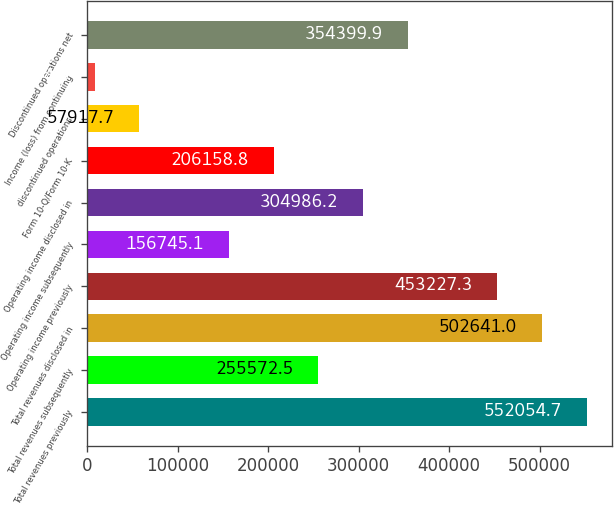<chart> <loc_0><loc_0><loc_500><loc_500><bar_chart><fcel>Total revenues previously<fcel>Total revenues subsequently<fcel>Total revenues disclosed in<fcel>Operating income previously<fcel>Operating income subsequently<fcel>Operating income disclosed in<fcel>Form 10-Q/Form 10-K<fcel>discontinued operations<fcel>Income (loss) from continuing<fcel>Discontinued operations net<nl><fcel>552055<fcel>255572<fcel>502641<fcel>453227<fcel>156745<fcel>304986<fcel>206159<fcel>57917.7<fcel>8504<fcel>354400<nl></chart> 